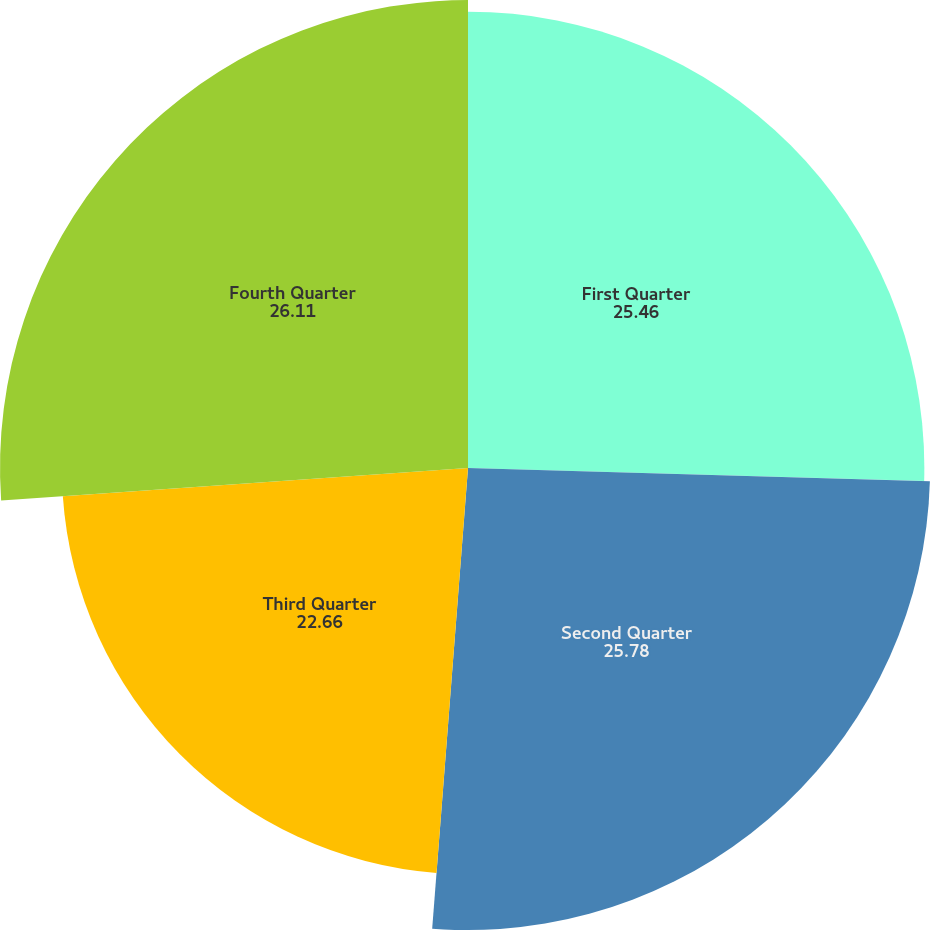Convert chart. <chart><loc_0><loc_0><loc_500><loc_500><pie_chart><fcel>First Quarter<fcel>Second Quarter<fcel>Third Quarter<fcel>Fourth Quarter<nl><fcel>25.46%<fcel>25.78%<fcel>22.66%<fcel>26.11%<nl></chart> 